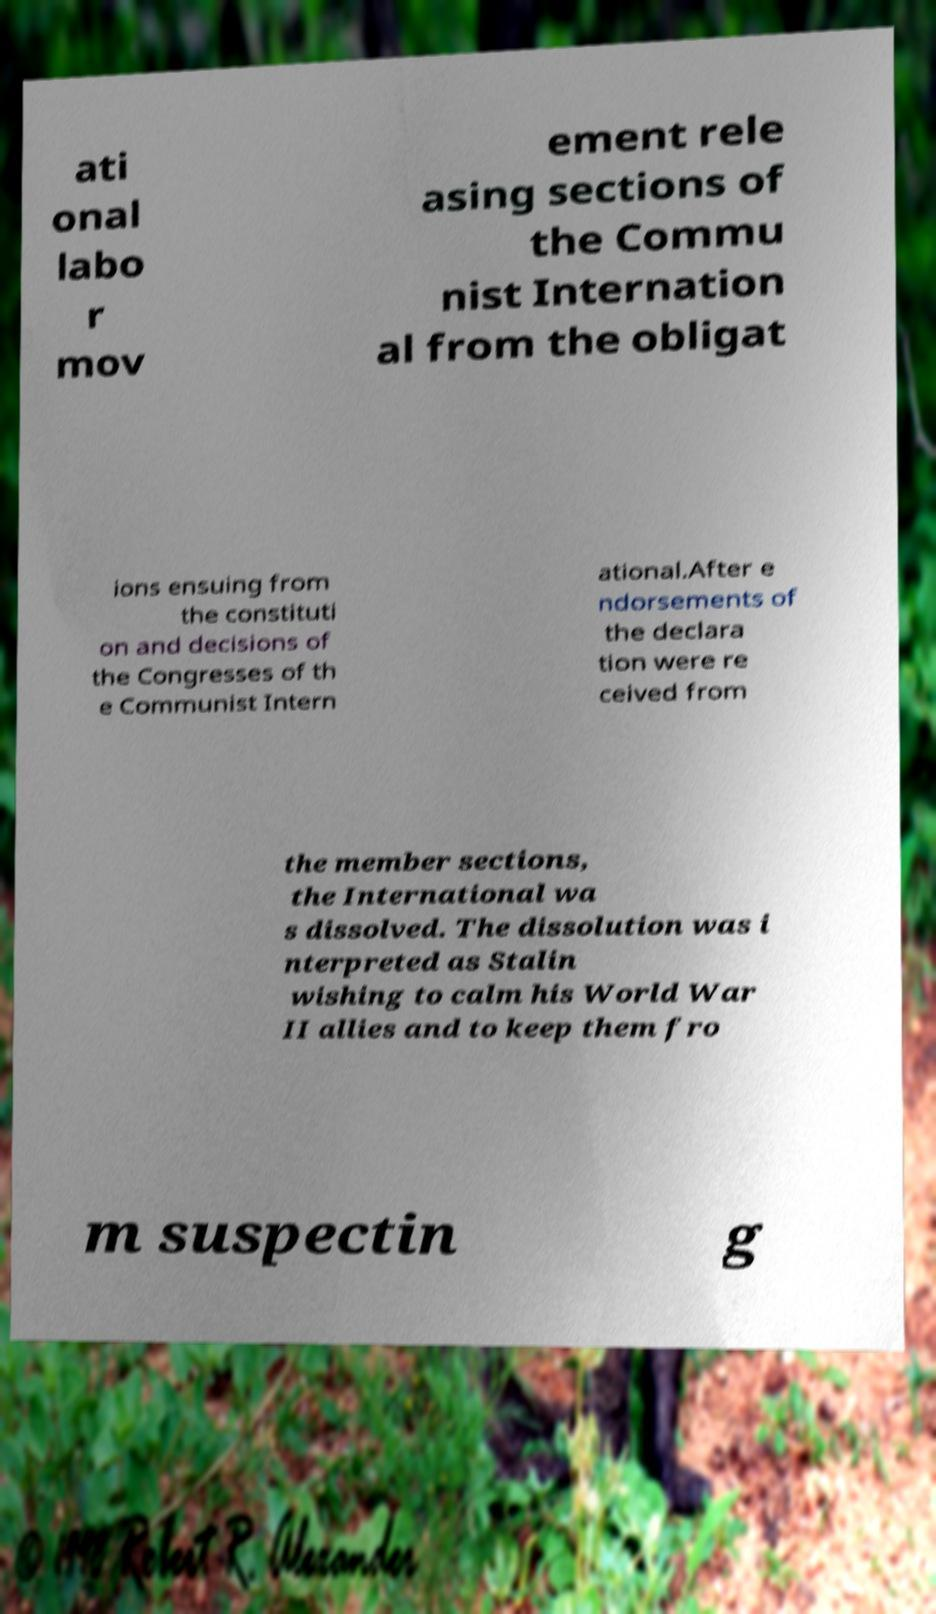What messages or text are displayed in this image? I need them in a readable, typed format. ati onal labo r mov ement rele asing sections of the Commu nist Internation al from the obligat ions ensuing from the constituti on and decisions of the Congresses of th e Communist Intern ational.After e ndorsements of the declara tion were re ceived from the member sections, the International wa s dissolved. The dissolution was i nterpreted as Stalin wishing to calm his World War II allies and to keep them fro m suspectin g 